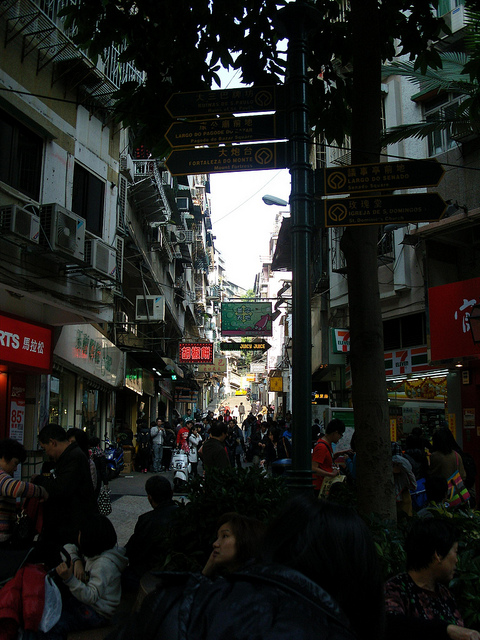Identify and read out the text in this image. RTS 85 